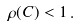Convert formula to latex. <formula><loc_0><loc_0><loc_500><loc_500>\rho ( C ) < 1 \, .</formula> 